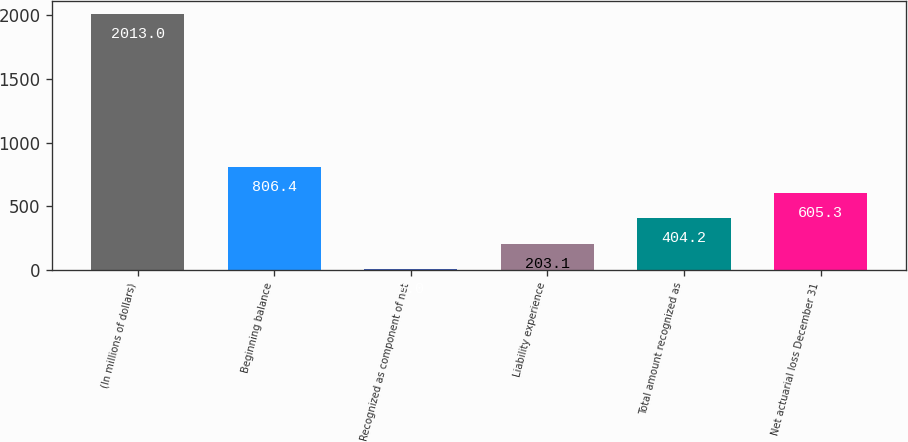Convert chart to OTSL. <chart><loc_0><loc_0><loc_500><loc_500><bar_chart><fcel>(In millions of dollars)<fcel>Beginning balance<fcel>Recognized as component of net<fcel>Liability experience<fcel>Total amount recognized as<fcel>Net actuarial loss December 31<nl><fcel>2013<fcel>806.4<fcel>2<fcel>203.1<fcel>404.2<fcel>605.3<nl></chart> 